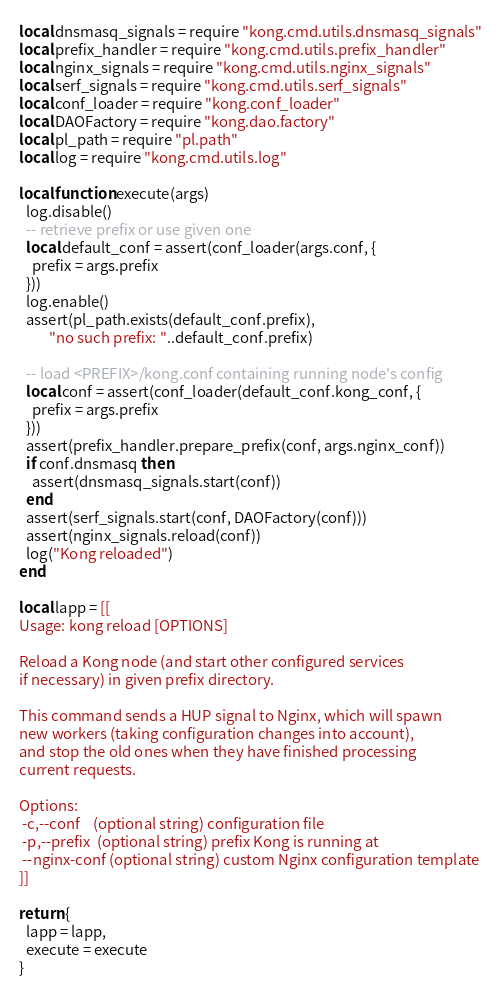<code> <loc_0><loc_0><loc_500><loc_500><_Lua_>local dnsmasq_signals = require "kong.cmd.utils.dnsmasq_signals"
local prefix_handler = require "kong.cmd.utils.prefix_handler"
local nginx_signals = require "kong.cmd.utils.nginx_signals"
local serf_signals = require "kong.cmd.utils.serf_signals"
local conf_loader = require "kong.conf_loader"
local DAOFactory = require "kong.dao.factory"
local pl_path = require "pl.path"
local log = require "kong.cmd.utils.log"

local function execute(args)
  log.disable()
  -- retrieve prefix or use given one
  local default_conf = assert(conf_loader(args.conf, {
    prefix = args.prefix
  }))
  log.enable()
  assert(pl_path.exists(default_conf.prefix),
         "no such prefix: "..default_conf.prefix)

  -- load <PREFIX>/kong.conf containing running node's config
  local conf = assert(conf_loader(default_conf.kong_conf, {
    prefix = args.prefix
  }))
  assert(prefix_handler.prepare_prefix(conf, args.nginx_conf))
  if conf.dnsmasq then
    assert(dnsmasq_signals.start(conf))
  end
  assert(serf_signals.start(conf, DAOFactory(conf)))
  assert(nginx_signals.reload(conf))
  log("Kong reloaded")
end

local lapp = [[
Usage: kong reload [OPTIONS]

Reload a Kong node (and start other configured services
if necessary) in given prefix directory.

This command sends a HUP signal to Nginx, which will spawn
new workers (taking configuration changes into account),
and stop the old ones when they have finished processing
current requests.

Options:
 -c,--conf    (optional string) configuration file
 -p,--prefix  (optional string) prefix Kong is running at
 --nginx-conf (optional string) custom Nginx configuration template
]]

return {
  lapp = lapp,
  execute = execute
}
</code> 